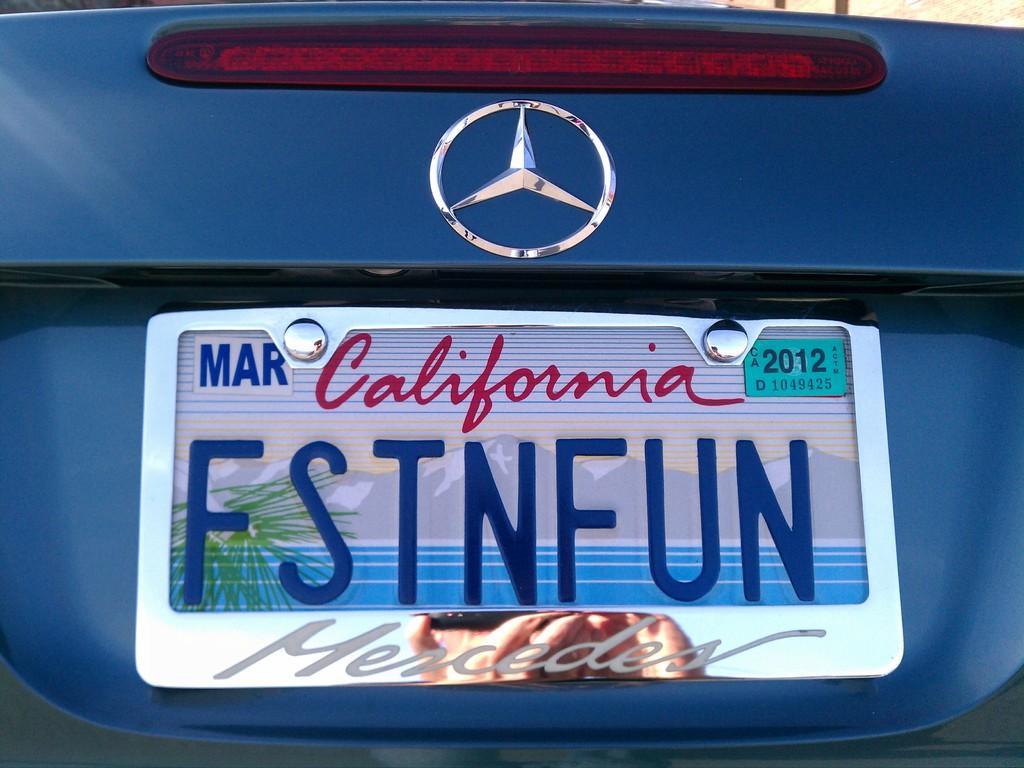Could you give a brief overview of what you see in this image? In this image we can see number plate on the car. 